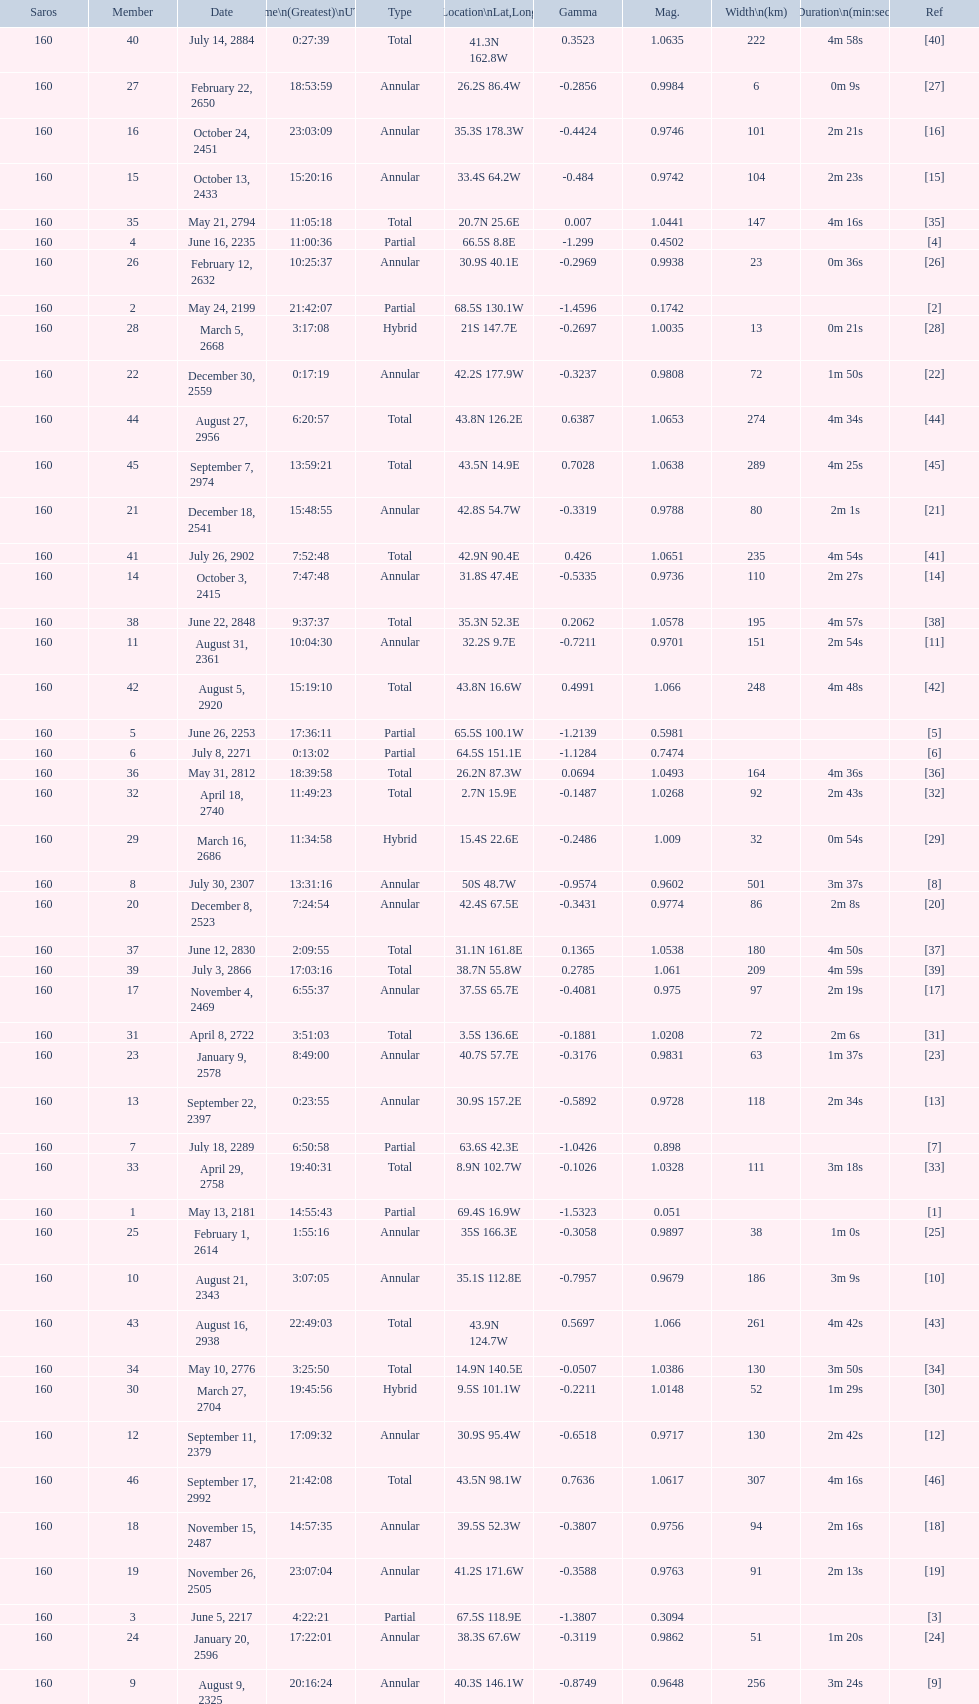When will the next solar saros be after the may 24, 2199 solar saros occurs? June 5, 2217. I'm looking to parse the entire table for insights. Could you assist me with that? {'header': ['Saros', 'Member', 'Date', 'Time\\n(Greatest)\\nUTC', 'Type', 'Location\\nLat,Long', 'Gamma', 'Mag.', 'Width\\n(km)', 'Duration\\n(min:sec)', 'Ref'], 'rows': [['160', '40', 'July 14, 2884', '0:27:39', 'Total', '41.3N 162.8W', '0.3523', '1.0635', '222', '4m 58s', '[40]'], ['160', '27', 'February 22, 2650', '18:53:59', 'Annular', '26.2S 86.4W', '-0.2856', '0.9984', '6', '0m 9s', '[27]'], ['160', '16', 'October 24, 2451', '23:03:09', 'Annular', '35.3S 178.3W', '-0.4424', '0.9746', '101', '2m 21s', '[16]'], ['160', '15', 'October 13, 2433', '15:20:16', 'Annular', '33.4S 64.2W', '-0.484', '0.9742', '104', '2m 23s', '[15]'], ['160', '35', 'May 21, 2794', '11:05:18', 'Total', '20.7N 25.6E', '0.007', '1.0441', '147', '4m 16s', '[35]'], ['160', '4', 'June 16, 2235', '11:00:36', 'Partial', '66.5S 8.8E', '-1.299', '0.4502', '', '', '[4]'], ['160', '26', 'February 12, 2632', '10:25:37', 'Annular', '30.9S 40.1E', '-0.2969', '0.9938', '23', '0m 36s', '[26]'], ['160', '2', 'May 24, 2199', '21:42:07', 'Partial', '68.5S 130.1W', '-1.4596', '0.1742', '', '', '[2]'], ['160', '28', 'March 5, 2668', '3:17:08', 'Hybrid', '21S 147.7E', '-0.2697', '1.0035', '13', '0m 21s', '[28]'], ['160', '22', 'December 30, 2559', '0:17:19', 'Annular', '42.2S 177.9W', '-0.3237', '0.9808', '72', '1m 50s', '[22]'], ['160', '44', 'August 27, 2956', '6:20:57', 'Total', '43.8N 126.2E', '0.6387', '1.0653', '274', '4m 34s', '[44]'], ['160', '45', 'September 7, 2974', '13:59:21', 'Total', '43.5N 14.9E', '0.7028', '1.0638', '289', '4m 25s', '[45]'], ['160', '21', 'December 18, 2541', '15:48:55', 'Annular', '42.8S 54.7W', '-0.3319', '0.9788', '80', '2m 1s', '[21]'], ['160', '41', 'July 26, 2902', '7:52:48', 'Total', '42.9N 90.4E', '0.426', '1.0651', '235', '4m 54s', '[41]'], ['160', '14', 'October 3, 2415', '7:47:48', 'Annular', '31.8S 47.4E', '-0.5335', '0.9736', '110', '2m 27s', '[14]'], ['160', '38', 'June 22, 2848', '9:37:37', 'Total', '35.3N 52.3E', '0.2062', '1.0578', '195', '4m 57s', '[38]'], ['160', '11', 'August 31, 2361', '10:04:30', 'Annular', '32.2S 9.7E', '-0.7211', '0.9701', '151', '2m 54s', '[11]'], ['160', '42', 'August 5, 2920', '15:19:10', 'Total', '43.8N 16.6W', '0.4991', '1.066', '248', '4m 48s', '[42]'], ['160', '5', 'June 26, 2253', '17:36:11', 'Partial', '65.5S 100.1W', '-1.2139', '0.5981', '', '', '[5]'], ['160', '6', 'July 8, 2271', '0:13:02', 'Partial', '64.5S 151.1E', '-1.1284', '0.7474', '', '', '[6]'], ['160', '36', 'May 31, 2812', '18:39:58', 'Total', '26.2N 87.3W', '0.0694', '1.0493', '164', '4m 36s', '[36]'], ['160', '32', 'April 18, 2740', '11:49:23', 'Total', '2.7N 15.9E', '-0.1487', '1.0268', '92', '2m 43s', '[32]'], ['160', '29', 'March 16, 2686', '11:34:58', 'Hybrid', '15.4S 22.6E', '-0.2486', '1.009', '32', '0m 54s', '[29]'], ['160', '8', 'July 30, 2307', '13:31:16', 'Annular', '50S 48.7W', '-0.9574', '0.9602', '501', '3m 37s', '[8]'], ['160', '20', 'December 8, 2523', '7:24:54', 'Annular', '42.4S 67.5E', '-0.3431', '0.9774', '86', '2m 8s', '[20]'], ['160', '37', 'June 12, 2830', '2:09:55', 'Total', '31.1N 161.8E', '0.1365', '1.0538', '180', '4m 50s', '[37]'], ['160', '39', 'July 3, 2866', '17:03:16', 'Total', '38.7N 55.8W', '0.2785', '1.061', '209', '4m 59s', '[39]'], ['160', '17', 'November 4, 2469', '6:55:37', 'Annular', '37.5S 65.7E', '-0.4081', '0.975', '97', '2m 19s', '[17]'], ['160', '31', 'April 8, 2722', '3:51:03', 'Total', '3.5S 136.6E', '-0.1881', '1.0208', '72', '2m 6s', '[31]'], ['160', '23', 'January 9, 2578', '8:49:00', 'Annular', '40.7S 57.7E', '-0.3176', '0.9831', '63', '1m 37s', '[23]'], ['160', '13', 'September 22, 2397', '0:23:55', 'Annular', '30.9S 157.2E', '-0.5892', '0.9728', '118', '2m 34s', '[13]'], ['160', '7', 'July 18, 2289', '6:50:58', 'Partial', '63.6S 42.3E', '-1.0426', '0.898', '', '', '[7]'], ['160', '33', 'April 29, 2758', '19:40:31', 'Total', '8.9N 102.7W', '-0.1026', '1.0328', '111', '3m 18s', '[33]'], ['160', '1', 'May 13, 2181', '14:55:43', 'Partial', '69.4S 16.9W', '-1.5323', '0.051', '', '', '[1]'], ['160', '25', 'February 1, 2614', '1:55:16', 'Annular', '35S 166.3E', '-0.3058', '0.9897', '38', '1m 0s', '[25]'], ['160', '10', 'August 21, 2343', '3:07:05', 'Annular', '35.1S 112.8E', '-0.7957', '0.9679', '186', '3m 9s', '[10]'], ['160', '43', 'August 16, 2938', '22:49:03', 'Total', '43.9N 124.7W', '0.5697', '1.066', '261', '4m 42s', '[43]'], ['160', '34', 'May 10, 2776', '3:25:50', 'Total', '14.9N 140.5E', '-0.0507', '1.0386', '130', '3m 50s', '[34]'], ['160', '30', 'March 27, 2704', '19:45:56', 'Hybrid', '9.5S 101.1W', '-0.2211', '1.0148', '52', '1m 29s', '[30]'], ['160', '12', 'September 11, 2379', '17:09:32', 'Annular', '30.9S 95.4W', '-0.6518', '0.9717', '130', '2m 42s', '[12]'], ['160', '46', 'September 17, 2992', '21:42:08', 'Total', '43.5N 98.1W', '0.7636', '1.0617', '307', '4m 16s', '[46]'], ['160', '18', 'November 15, 2487', '14:57:35', 'Annular', '39.5S 52.3W', '-0.3807', '0.9756', '94', '2m 16s', '[18]'], ['160', '19', 'November 26, 2505', '23:07:04', 'Annular', '41.2S 171.6W', '-0.3588', '0.9763', '91', '2m 13s', '[19]'], ['160', '3', 'June 5, 2217', '4:22:21', 'Partial', '67.5S 118.9E', '-1.3807', '0.3094', '', '', '[3]'], ['160', '24', 'January 20, 2596', '17:22:01', 'Annular', '38.3S 67.6W', '-0.3119', '0.9862', '51', '1m 20s', '[24]'], ['160', '9', 'August 9, 2325', '20:16:24', 'Annular', '40.3S 146.1W', '-0.8749', '0.9648', '256', '3m 24s', '[9]']]} 